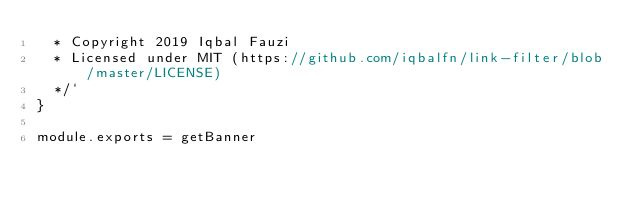Convert code to text. <code><loc_0><loc_0><loc_500><loc_500><_JavaScript_>  * Copyright 2019 Iqbal Fauzi
  * Licensed under MIT (https://github.com/iqbalfn/link-filter/blob/master/LICENSE)
  */`
}

module.exports = getBanner
</code> 